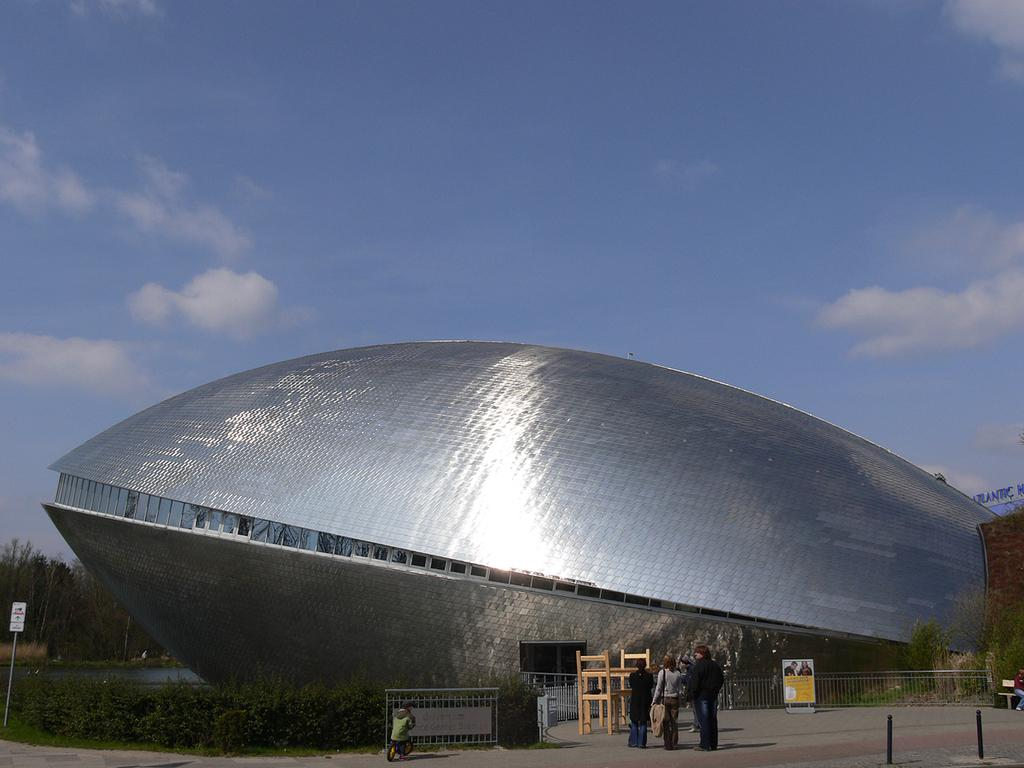What type of structure is depicted in the image? There is an architecture building in the image. What objects can be seen near the building? There are boards and railings in the image. What type of vegetation is present in the image? There are plants and trees in the image. What is the condition of the sky in the image? The sky is cloudy in the image. Are there any people visible in the image? Yes, there are people in front of the building. What type of meat is being served at the country fair in the image? There is no country fair or meat present in the image; it features an architecture building, boards, railings, plants, trees, a cloudy sky, and people. 